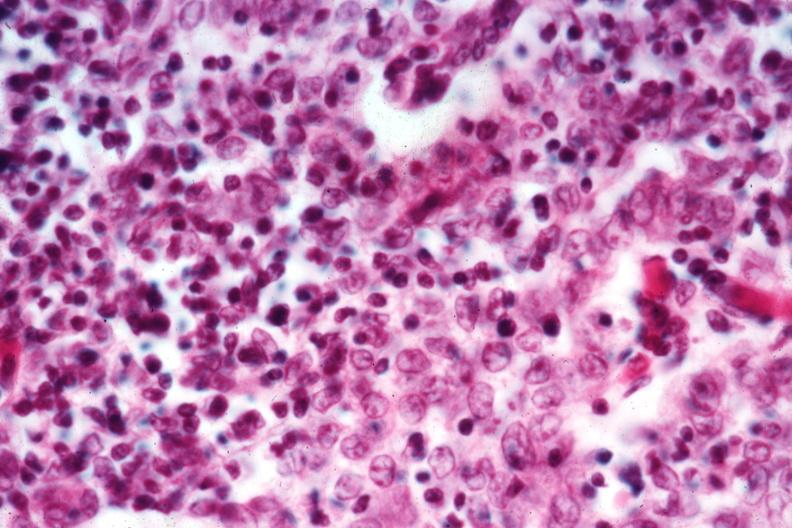what well shown?
Answer the question using a single word or phrase. Cellular detail 